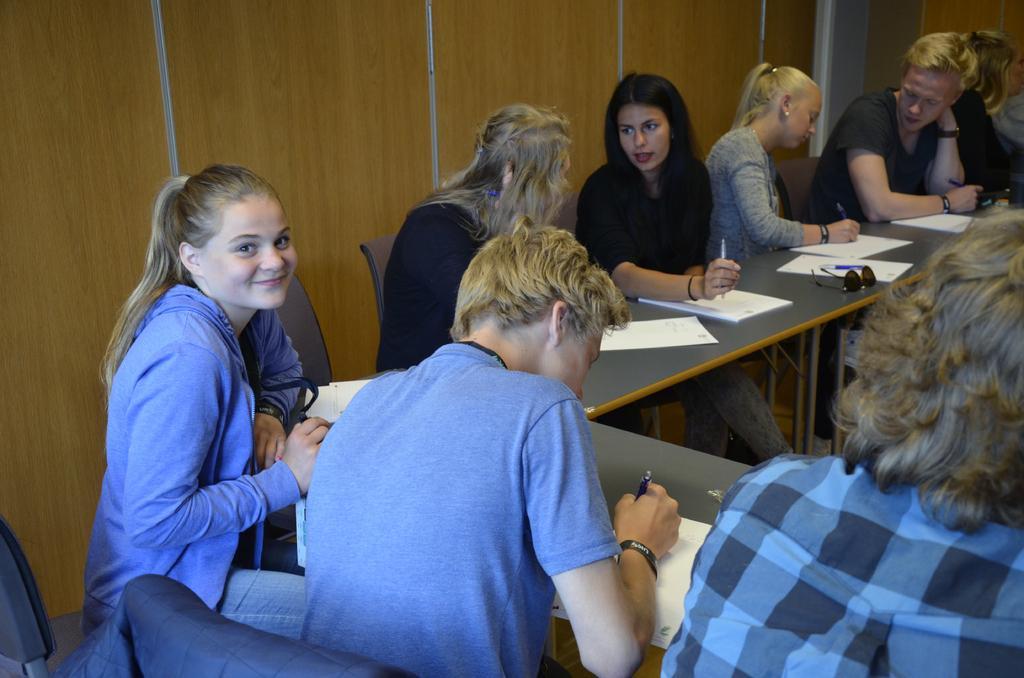Could you give a brief overview of what you see in this image? In the picture there are many people sitting on the chair with the table in front of them, on the table there are books and they are catching pens with their hands. 